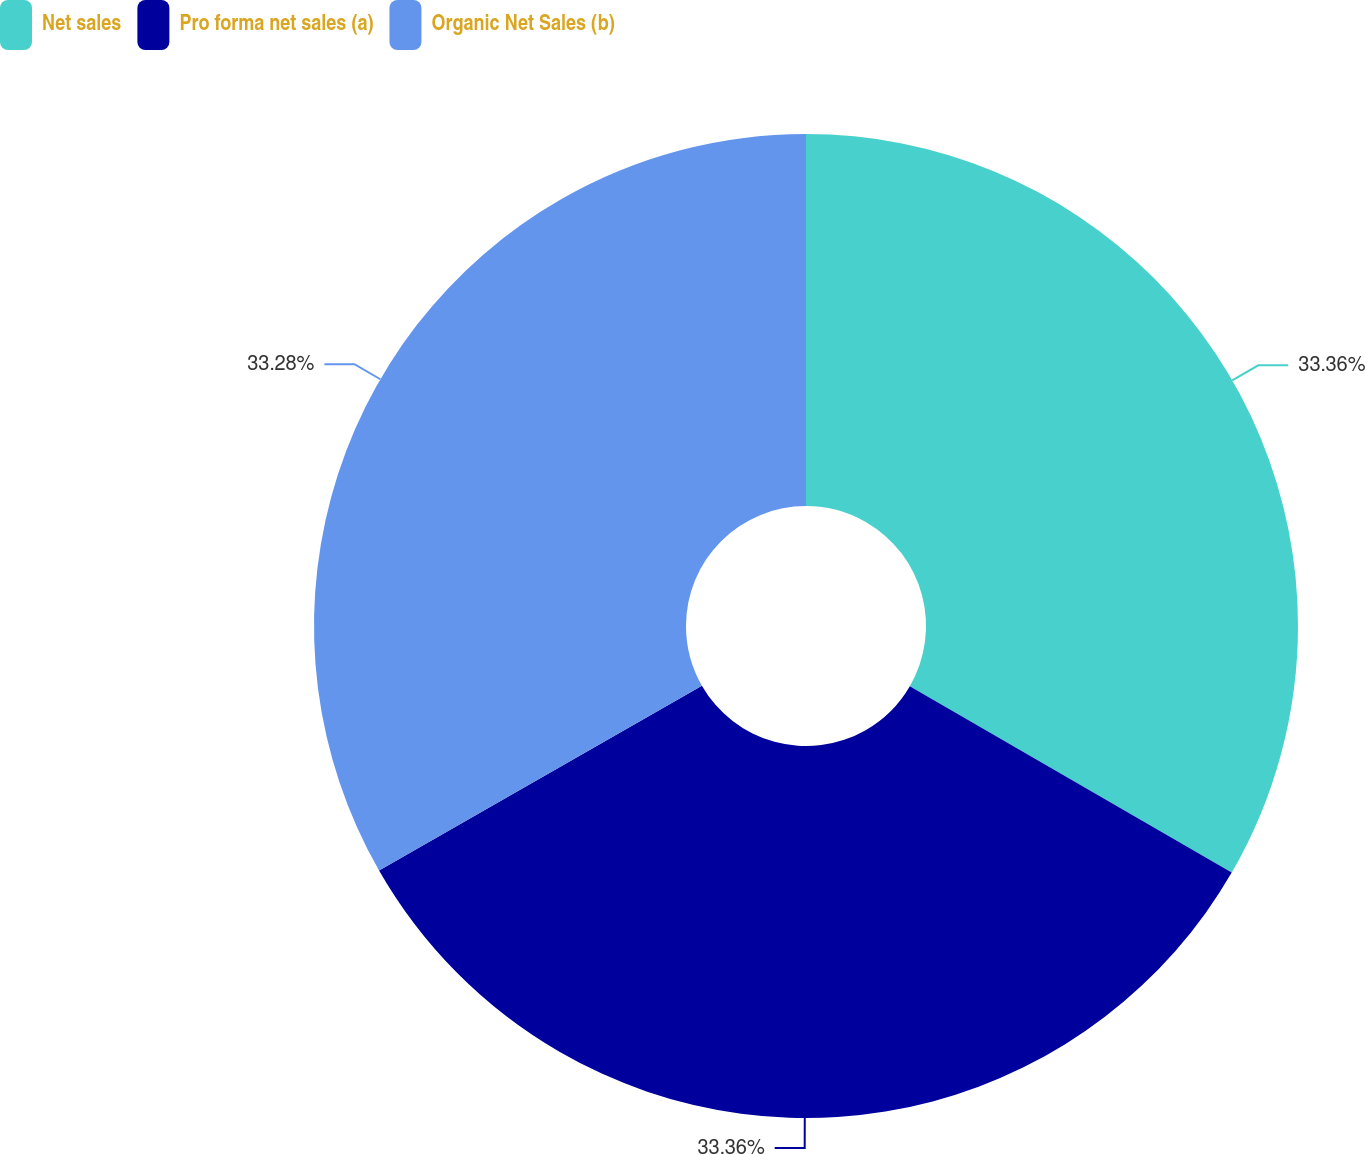Convert chart to OTSL. <chart><loc_0><loc_0><loc_500><loc_500><pie_chart><fcel>Net sales<fcel>Pro forma net sales (a)<fcel>Organic Net Sales (b)<nl><fcel>33.36%<fcel>33.37%<fcel>33.28%<nl></chart> 